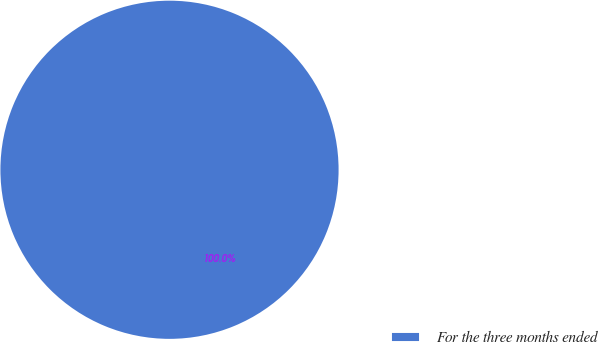Convert chart. <chart><loc_0><loc_0><loc_500><loc_500><pie_chart><fcel>For the three months ended<nl><fcel>100.0%<nl></chart> 